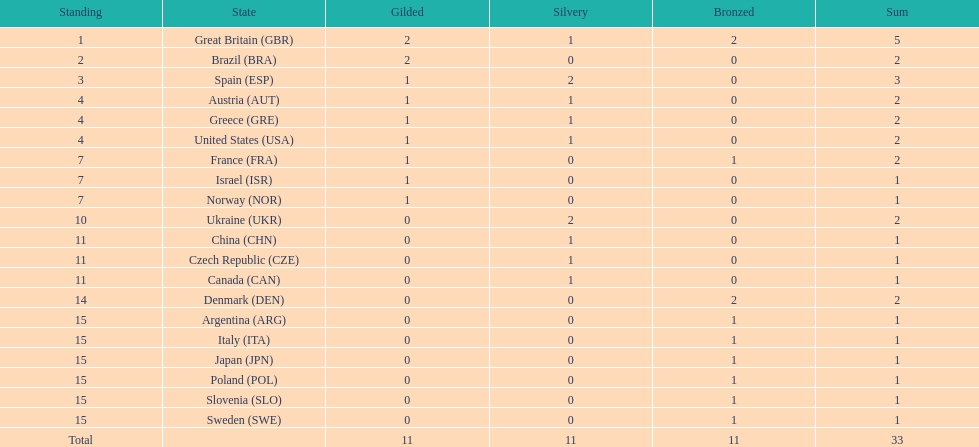What country had the most medals? Great Britain. 